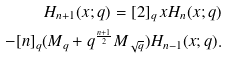<formula> <loc_0><loc_0><loc_500><loc_500>H _ { n + 1 } ( x ; q ) = [ 2 ] _ { q } \, x H _ { n } ( x ; q ) \\ - [ n ] _ { q } ( M _ { q } + q ^ { \frac { n + 1 } { 2 } } M _ { \sqrt { q } } ) H _ { n - 1 } ( x ; q ) .</formula> 